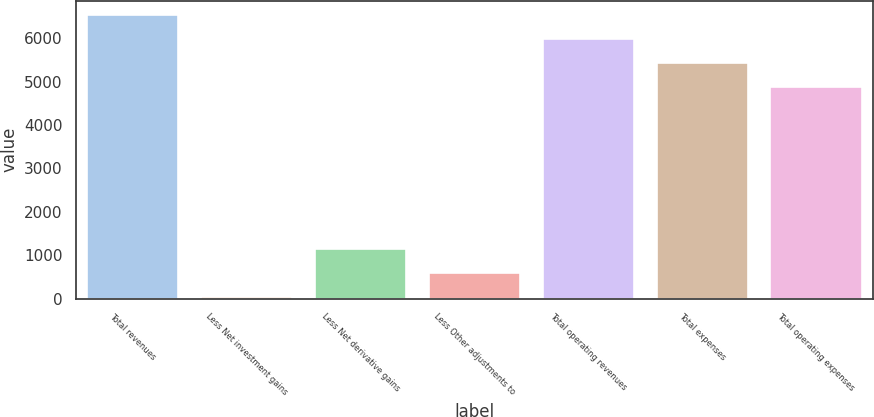Convert chart to OTSL. <chart><loc_0><loc_0><loc_500><loc_500><bar_chart><fcel>Total revenues<fcel>Less Net investment gains<fcel>Less Net derivative gains<fcel>Less Other adjustments to<fcel>Total operating revenues<fcel>Total expenses<fcel>Total operating expenses<nl><fcel>6535.2<fcel>30<fcel>1134.8<fcel>582.4<fcel>5982.8<fcel>5430.4<fcel>4878<nl></chart> 